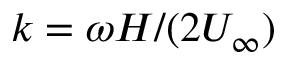<formula> <loc_0><loc_0><loc_500><loc_500>k = \omega H / ( 2 U _ { \infty } )</formula> 